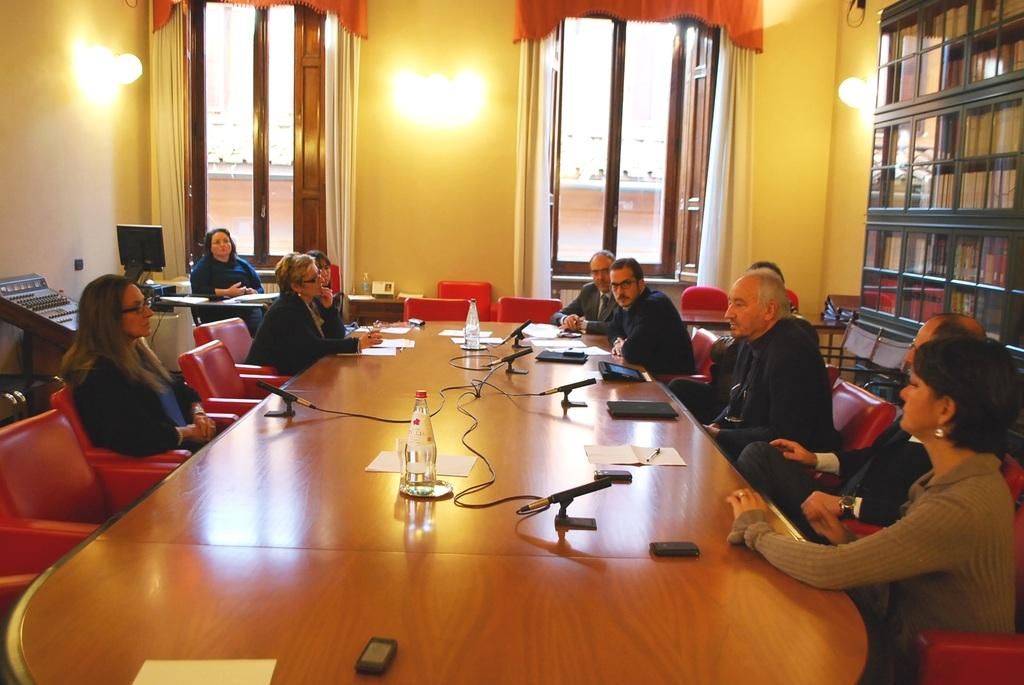What is the main subject of the image? The main subject of the image is a group of people. What are the people in the image doing? The people are sitting on chairs in the image. What can be seen on the left side of the image? There is a window on the left side of the image. What is located near the window? There is a light near the window. What type of corn is being grown in the image? There is no corn present in the image. What is the group of people's desire in the image? The image does not provide information about the group's desires, as it only shows them sitting on chairs. 